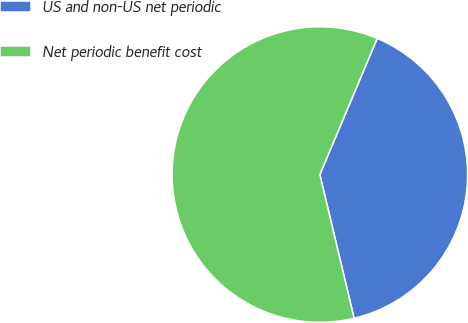Convert chart. <chart><loc_0><loc_0><loc_500><loc_500><pie_chart><fcel>US and non-US net periodic<fcel>Net periodic benefit cost<nl><fcel>39.93%<fcel>60.07%<nl></chart> 